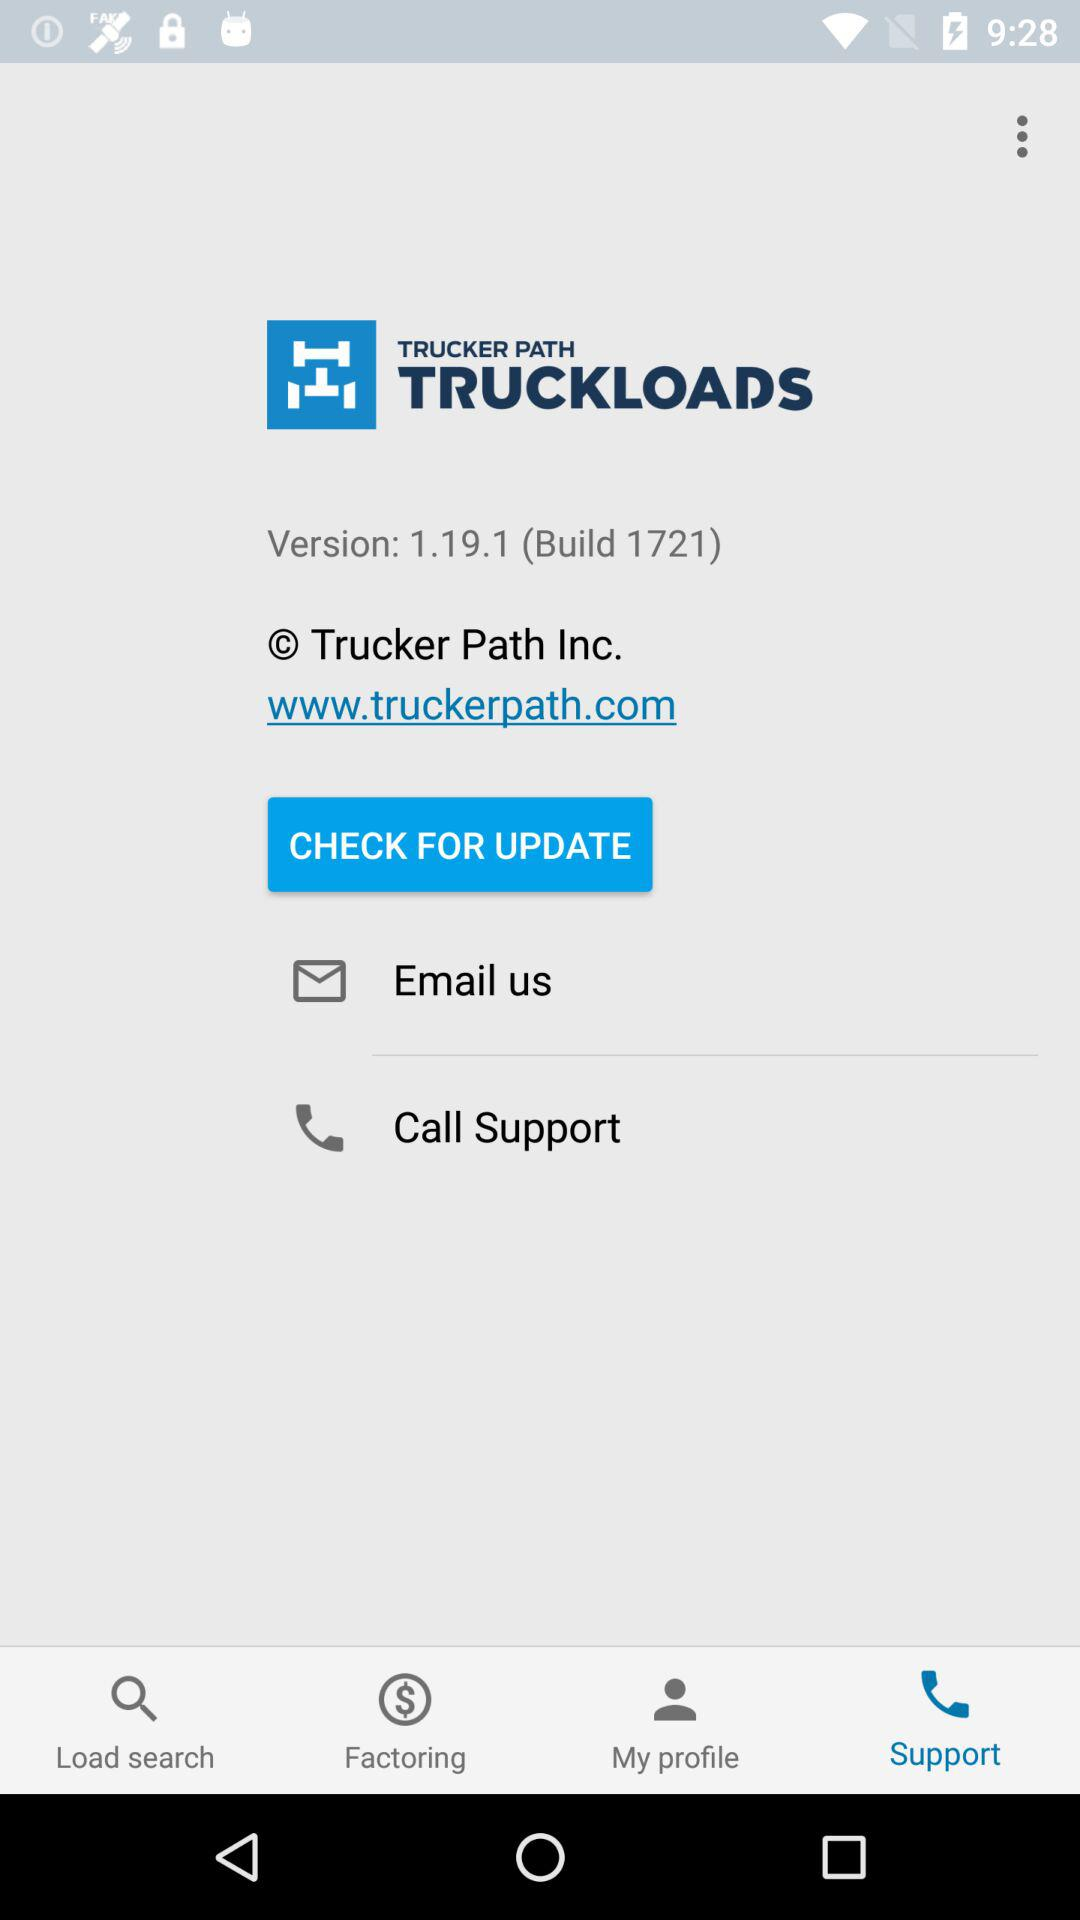What application is asking for an update? The application asking for an update is "TRUCKLOADS". 